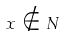Convert formula to latex. <formula><loc_0><loc_0><loc_500><loc_500>x \notin N</formula> 